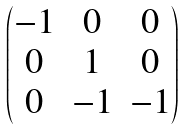Convert formula to latex. <formula><loc_0><loc_0><loc_500><loc_500>\begin{pmatrix} - 1 & 0 & 0 \\ 0 & 1 & 0 \\ 0 & - 1 & - 1 \end{pmatrix}</formula> 